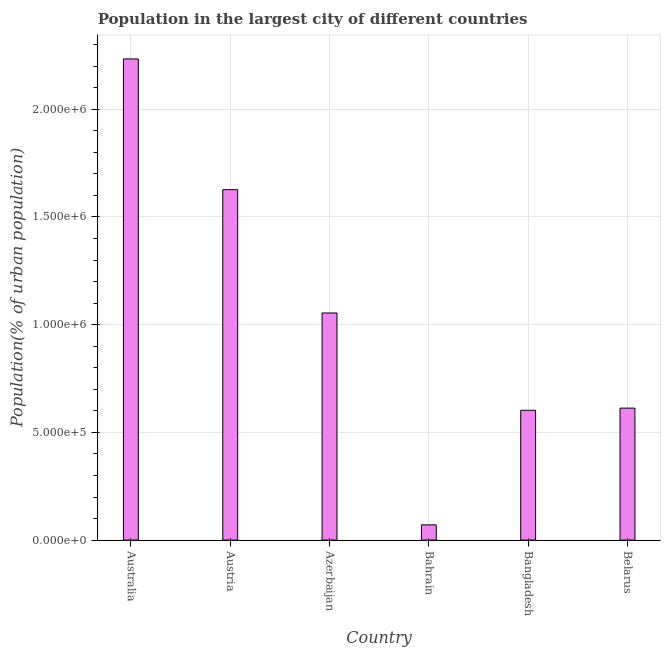Does the graph contain any zero values?
Offer a terse response. No. Does the graph contain grids?
Offer a terse response. Yes. What is the title of the graph?
Make the answer very short. Population in the largest city of different countries. What is the label or title of the X-axis?
Keep it short and to the point. Country. What is the label or title of the Y-axis?
Keep it short and to the point. Population(% of urban population). What is the population in largest city in Australia?
Your answer should be compact. 2.23e+06. Across all countries, what is the maximum population in largest city?
Your answer should be compact. 2.23e+06. Across all countries, what is the minimum population in largest city?
Your response must be concise. 7.07e+04. In which country was the population in largest city minimum?
Provide a short and direct response. Bahrain. What is the sum of the population in largest city?
Ensure brevity in your answer.  6.20e+06. What is the difference between the population in largest city in Austria and Bahrain?
Offer a terse response. 1.56e+06. What is the average population in largest city per country?
Provide a succinct answer. 1.03e+06. What is the median population in largest city?
Make the answer very short. 8.33e+05. In how many countries, is the population in largest city greater than 1000000 %?
Your answer should be compact. 3. What is the ratio of the population in largest city in Bahrain to that in Bangladesh?
Give a very brief answer. 0.12. Is the difference between the population in largest city in Australia and Belarus greater than the difference between any two countries?
Offer a very short reply. No. What is the difference between the highest and the second highest population in largest city?
Offer a very short reply. 6.07e+05. Is the sum of the population in largest city in Bahrain and Belarus greater than the maximum population in largest city across all countries?
Provide a short and direct response. No. What is the difference between the highest and the lowest population in largest city?
Keep it short and to the point. 2.16e+06. What is the difference between two consecutive major ticks on the Y-axis?
Offer a very short reply. 5.00e+05. What is the Population(% of urban population) of Australia?
Provide a succinct answer. 2.23e+06. What is the Population(% of urban population) in Austria?
Provide a succinct answer. 1.63e+06. What is the Population(% of urban population) of Azerbaijan?
Provide a succinct answer. 1.05e+06. What is the Population(% of urban population) in Bahrain?
Your response must be concise. 7.07e+04. What is the Population(% of urban population) of Bangladesh?
Keep it short and to the point. 6.03e+05. What is the Population(% of urban population) in Belarus?
Your response must be concise. 6.13e+05. What is the difference between the Population(% of urban population) in Australia and Austria?
Keep it short and to the point. 6.07e+05. What is the difference between the Population(% of urban population) in Australia and Azerbaijan?
Your response must be concise. 1.18e+06. What is the difference between the Population(% of urban population) in Australia and Bahrain?
Give a very brief answer. 2.16e+06. What is the difference between the Population(% of urban population) in Australia and Bangladesh?
Your answer should be compact. 1.63e+06. What is the difference between the Population(% of urban population) in Australia and Belarus?
Provide a succinct answer. 1.62e+06. What is the difference between the Population(% of urban population) in Austria and Azerbaijan?
Your answer should be very brief. 5.72e+05. What is the difference between the Population(% of urban population) in Austria and Bahrain?
Keep it short and to the point. 1.56e+06. What is the difference between the Population(% of urban population) in Austria and Bangladesh?
Give a very brief answer. 1.02e+06. What is the difference between the Population(% of urban population) in Austria and Belarus?
Your answer should be compact. 1.01e+06. What is the difference between the Population(% of urban population) in Azerbaijan and Bahrain?
Keep it short and to the point. 9.83e+05. What is the difference between the Population(% of urban population) in Azerbaijan and Bangladesh?
Offer a terse response. 4.52e+05. What is the difference between the Population(% of urban population) in Azerbaijan and Belarus?
Provide a succinct answer. 4.42e+05. What is the difference between the Population(% of urban population) in Bahrain and Bangladesh?
Keep it short and to the point. -5.32e+05. What is the difference between the Population(% of urban population) in Bahrain and Belarus?
Give a very brief answer. -5.42e+05. What is the difference between the Population(% of urban population) in Bangladesh and Belarus?
Ensure brevity in your answer.  -1.01e+04. What is the ratio of the Population(% of urban population) in Australia to that in Austria?
Your answer should be compact. 1.37. What is the ratio of the Population(% of urban population) in Australia to that in Azerbaijan?
Make the answer very short. 2.12. What is the ratio of the Population(% of urban population) in Australia to that in Bahrain?
Keep it short and to the point. 31.59. What is the ratio of the Population(% of urban population) in Australia to that in Bangladesh?
Offer a terse response. 3.71. What is the ratio of the Population(% of urban population) in Australia to that in Belarus?
Make the answer very short. 3.65. What is the ratio of the Population(% of urban population) in Austria to that in Azerbaijan?
Provide a short and direct response. 1.54. What is the ratio of the Population(% of urban population) in Austria to that in Bahrain?
Make the answer very short. 23.01. What is the ratio of the Population(% of urban population) in Austria to that in Belarus?
Offer a terse response. 2.65. What is the ratio of the Population(% of urban population) in Azerbaijan to that in Bahrain?
Offer a very short reply. 14.91. What is the ratio of the Population(% of urban population) in Azerbaijan to that in Belarus?
Make the answer very short. 1.72. What is the ratio of the Population(% of urban population) in Bahrain to that in Bangladesh?
Offer a very short reply. 0.12. What is the ratio of the Population(% of urban population) in Bahrain to that in Belarus?
Provide a short and direct response. 0.12. What is the ratio of the Population(% of urban population) in Bangladesh to that in Belarus?
Your answer should be compact. 0.98. 